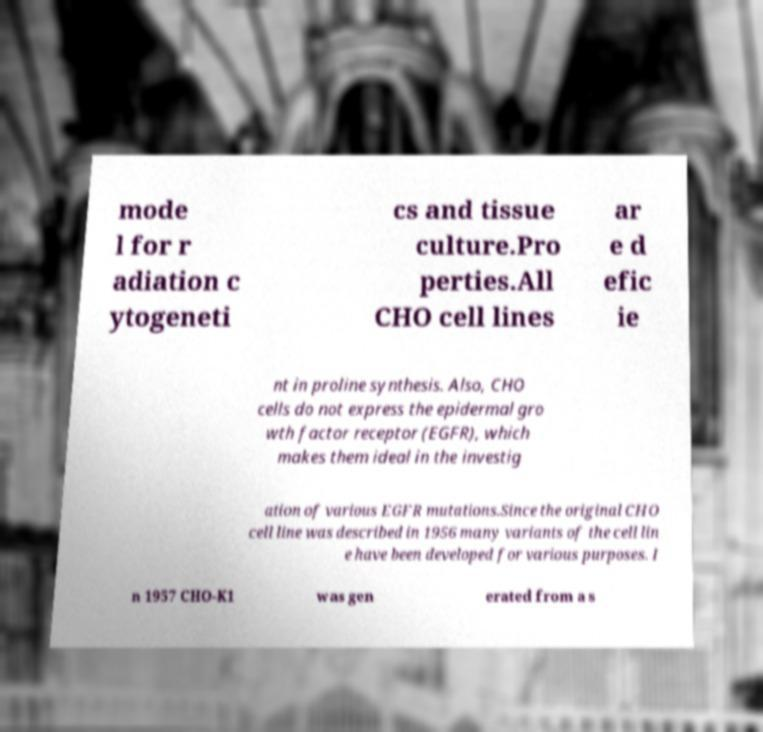Could you extract and type out the text from this image? mode l for r adiation c ytogeneti cs and tissue culture.Pro perties.All CHO cell lines ar e d efic ie nt in proline synthesis. Also, CHO cells do not express the epidermal gro wth factor receptor (EGFR), which makes them ideal in the investig ation of various EGFR mutations.Since the original CHO cell line was described in 1956 many variants of the cell lin e have been developed for various purposes. I n 1957 CHO-K1 was gen erated from a s 